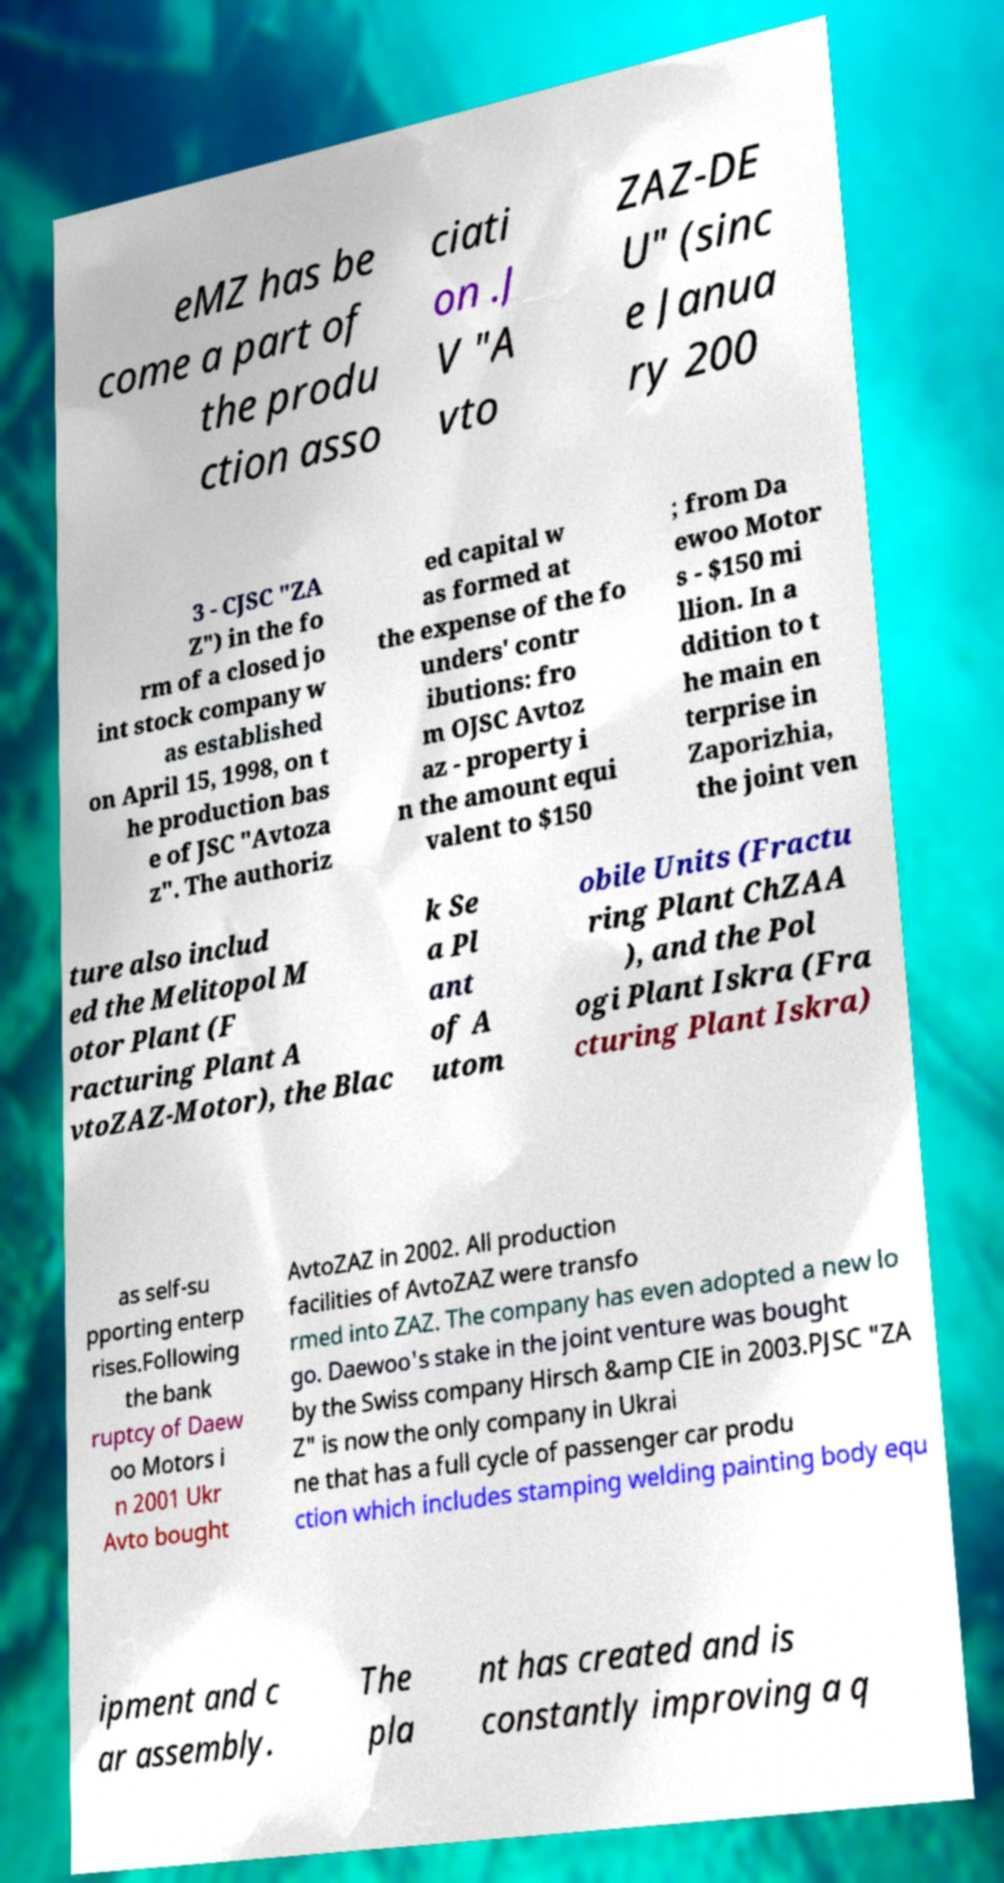Could you extract and type out the text from this image? eMZ has be come a part of the produ ction asso ciati on .J V "A vto ZAZ-DE U" (sinc e Janua ry 200 3 - CJSC "ZA Z") in the fo rm of a closed jo int stock company w as established on April 15, 1998, on t he production bas e of JSC "Avtoza z". The authoriz ed capital w as formed at the expense of the fo unders' contr ibutions: fro m OJSC Avtoz az - property i n the amount equi valent to $150 ; from Da ewoo Motor s - $150 mi llion. In a ddition to t he main en terprise in Zaporizhia, the joint ven ture also includ ed the Melitopol M otor Plant (F racturing Plant A vtoZAZ-Motor), the Blac k Se a Pl ant of A utom obile Units (Fractu ring Plant ChZAA ), and the Pol ogi Plant Iskra (Fra cturing Plant Iskra) as self-su pporting enterp rises.Following the bank ruptcy of Daew oo Motors i n 2001 Ukr Avto bought AvtoZAZ in 2002. All production facilities of AvtoZAZ were transfo rmed into ZAZ. The company has even adopted a new lo go. Daewoo's stake in the joint venture was bought by the Swiss company Hirsch &amp CIE in 2003.PJSC "ZA Z" is now the only company in Ukrai ne that has a full cycle of passenger car produ ction which includes stamping welding painting body equ ipment and c ar assembly. The pla nt has created and is constantly improving a q 